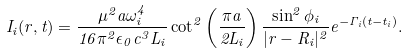<formula> <loc_0><loc_0><loc_500><loc_500>I _ { i } ( { r } , t ) = \frac { \mu ^ { 2 } a \omega _ { i } ^ { 4 } } { 1 6 \pi ^ { 2 } \epsilon _ { 0 } c ^ { 3 } L _ { i } } \cot ^ { 2 } \left ( \frac { \pi a } { 2 L _ { i } } \right ) \frac { \sin ^ { 2 } \phi _ { i } } { | { r } - { R } _ { i } | ^ { 2 } } e ^ { - \Gamma _ { i } ( t - t _ { i } ) } .</formula> 